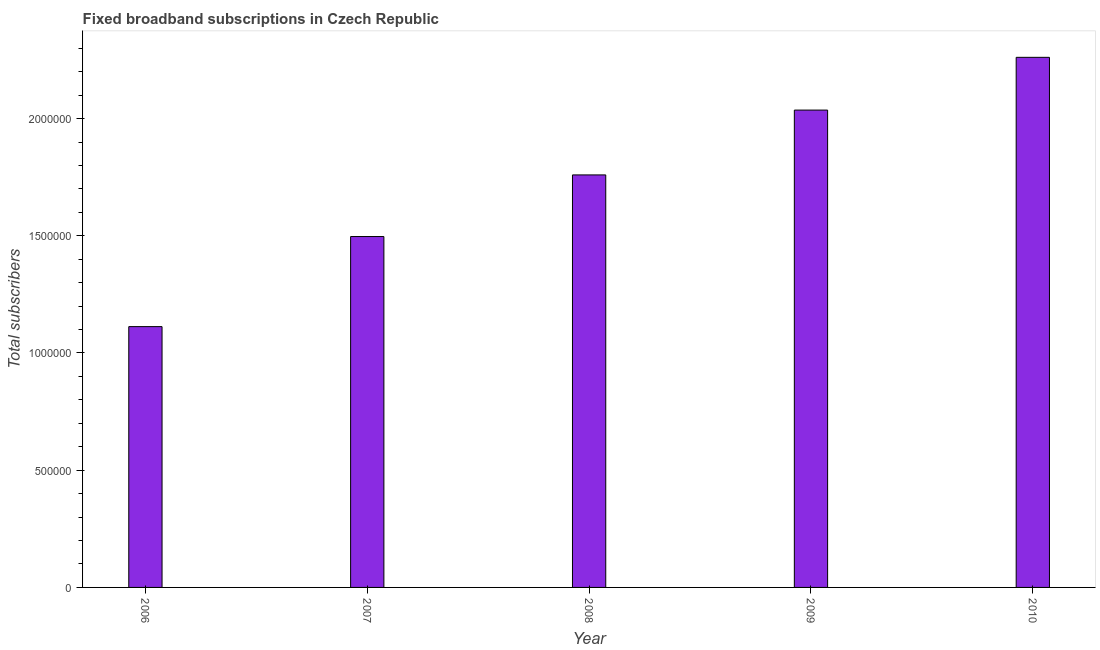What is the title of the graph?
Ensure brevity in your answer.  Fixed broadband subscriptions in Czech Republic. What is the label or title of the X-axis?
Ensure brevity in your answer.  Year. What is the label or title of the Y-axis?
Your response must be concise. Total subscribers. What is the total number of fixed broadband subscriptions in 2006?
Give a very brief answer. 1.11e+06. Across all years, what is the maximum total number of fixed broadband subscriptions?
Offer a terse response. 2.26e+06. Across all years, what is the minimum total number of fixed broadband subscriptions?
Give a very brief answer. 1.11e+06. What is the sum of the total number of fixed broadband subscriptions?
Provide a short and direct response. 8.67e+06. What is the difference between the total number of fixed broadband subscriptions in 2007 and 2010?
Your answer should be compact. -7.64e+05. What is the average total number of fixed broadband subscriptions per year?
Offer a terse response. 1.73e+06. What is the median total number of fixed broadband subscriptions?
Make the answer very short. 1.76e+06. In how many years, is the total number of fixed broadband subscriptions greater than 700000 ?
Provide a succinct answer. 5. Do a majority of the years between 2008 and 2007 (inclusive) have total number of fixed broadband subscriptions greater than 2100000 ?
Offer a terse response. No. What is the ratio of the total number of fixed broadband subscriptions in 2006 to that in 2007?
Ensure brevity in your answer.  0.74. What is the difference between the highest and the second highest total number of fixed broadband subscriptions?
Provide a short and direct response. 2.25e+05. What is the difference between the highest and the lowest total number of fixed broadband subscriptions?
Offer a terse response. 1.15e+06. In how many years, is the total number of fixed broadband subscriptions greater than the average total number of fixed broadband subscriptions taken over all years?
Ensure brevity in your answer.  3. How many bars are there?
Your response must be concise. 5. Are all the bars in the graph horizontal?
Offer a very short reply. No. How many years are there in the graph?
Provide a succinct answer. 5. What is the difference between two consecutive major ticks on the Y-axis?
Ensure brevity in your answer.  5.00e+05. What is the Total subscribers of 2006?
Offer a very short reply. 1.11e+06. What is the Total subscribers in 2007?
Provide a short and direct response. 1.50e+06. What is the Total subscribers of 2008?
Ensure brevity in your answer.  1.76e+06. What is the Total subscribers in 2009?
Make the answer very short. 2.04e+06. What is the Total subscribers in 2010?
Make the answer very short. 2.26e+06. What is the difference between the Total subscribers in 2006 and 2007?
Provide a succinct answer. -3.84e+05. What is the difference between the Total subscribers in 2006 and 2008?
Your answer should be very brief. -6.47e+05. What is the difference between the Total subscribers in 2006 and 2009?
Keep it short and to the point. -9.24e+05. What is the difference between the Total subscribers in 2006 and 2010?
Offer a terse response. -1.15e+06. What is the difference between the Total subscribers in 2007 and 2008?
Your answer should be compact. -2.63e+05. What is the difference between the Total subscribers in 2007 and 2009?
Provide a succinct answer. -5.39e+05. What is the difference between the Total subscribers in 2007 and 2010?
Offer a terse response. -7.64e+05. What is the difference between the Total subscribers in 2008 and 2009?
Your answer should be compact. -2.77e+05. What is the difference between the Total subscribers in 2008 and 2010?
Your response must be concise. -5.02e+05. What is the difference between the Total subscribers in 2009 and 2010?
Your response must be concise. -2.25e+05. What is the ratio of the Total subscribers in 2006 to that in 2007?
Give a very brief answer. 0.74. What is the ratio of the Total subscribers in 2006 to that in 2008?
Ensure brevity in your answer.  0.63. What is the ratio of the Total subscribers in 2006 to that in 2009?
Your response must be concise. 0.55. What is the ratio of the Total subscribers in 2006 to that in 2010?
Ensure brevity in your answer.  0.49. What is the ratio of the Total subscribers in 2007 to that in 2008?
Give a very brief answer. 0.85. What is the ratio of the Total subscribers in 2007 to that in 2009?
Provide a succinct answer. 0.73. What is the ratio of the Total subscribers in 2007 to that in 2010?
Keep it short and to the point. 0.66. What is the ratio of the Total subscribers in 2008 to that in 2009?
Your response must be concise. 0.86. What is the ratio of the Total subscribers in 2008 to that in 2010?
Keep it short and to the point. 0.78. What is the ratio of the Total subscribers in 2009 to that in 2010?
Your response must be concise. 0.9. 